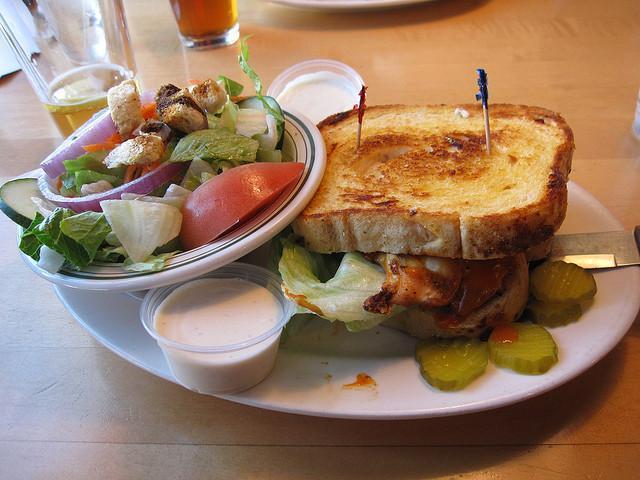How many pickles are there?
Give a very brief answer. 3. How many cups are in the picture?
Give a very brief answer. 2. 